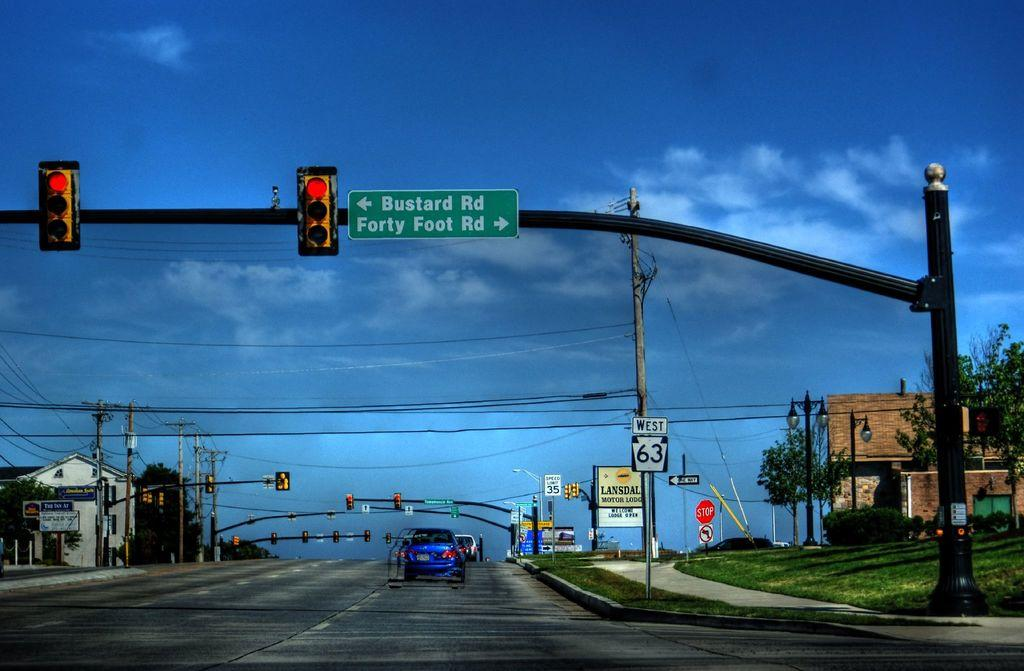Provide a one-sentence caption for the provided image. A large green and white road sign displayed above a highway that says Buster Rd and Forty Foot Rd. 